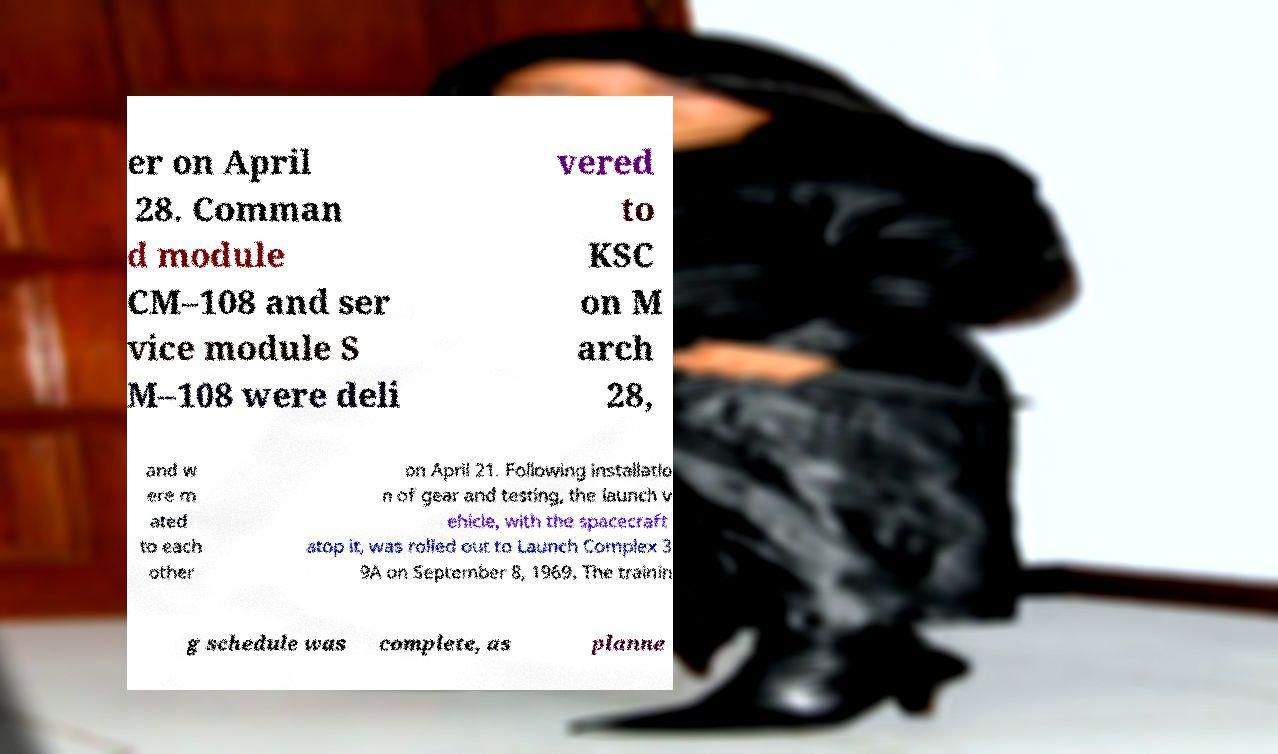Could you assist in decoding the text presented in this image and type it out clearly? er on April 28. Comman d module CM–108 and ser vice module S M–108 were deli vered to KSC on M arch 28, and w ere m ated to each other on April 21. Following installatio n of gear and testing, the launch v ehicle, with the spacecraft atop it, was rolled out to Launch Complex 3 9A on September 8, 1969. The trainin g schedule was complete, as planne 